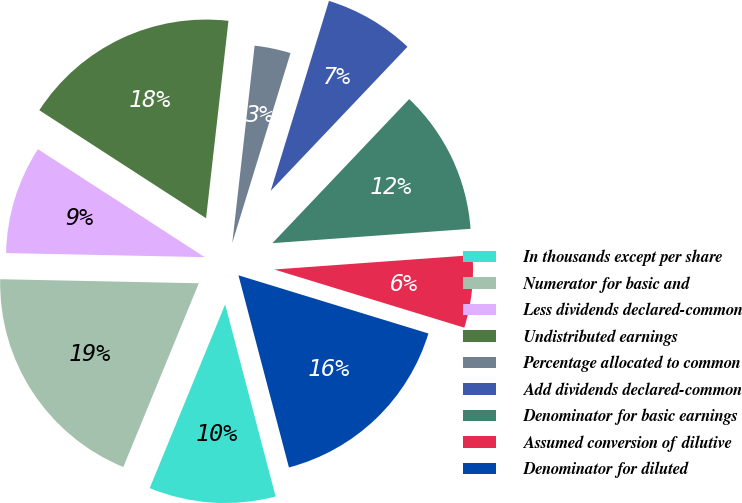<chart> <loc_0><loc_0><loc_500><loc_500><pie_chart><fcel>In thousands except per share<fcel>Numerator for basic and<fcel>Less dividends declared-common<fcel>Undistributed earnings<fcel>Percentage allocated to common<fcel>Add dividends declared-common<fcel>Denominator for basic earnings<fcel>Assumed conversion of dilutive<fcel>Denominator for diluted<nl><fcel>10.29%<fcel>19.12%<fcel>8.82%<fcel>17.65%<fcel>2.94%<fcel>7.35%<fcel>11.76%<fcel>5.88%<fcel>16.18%<nl></chart> 